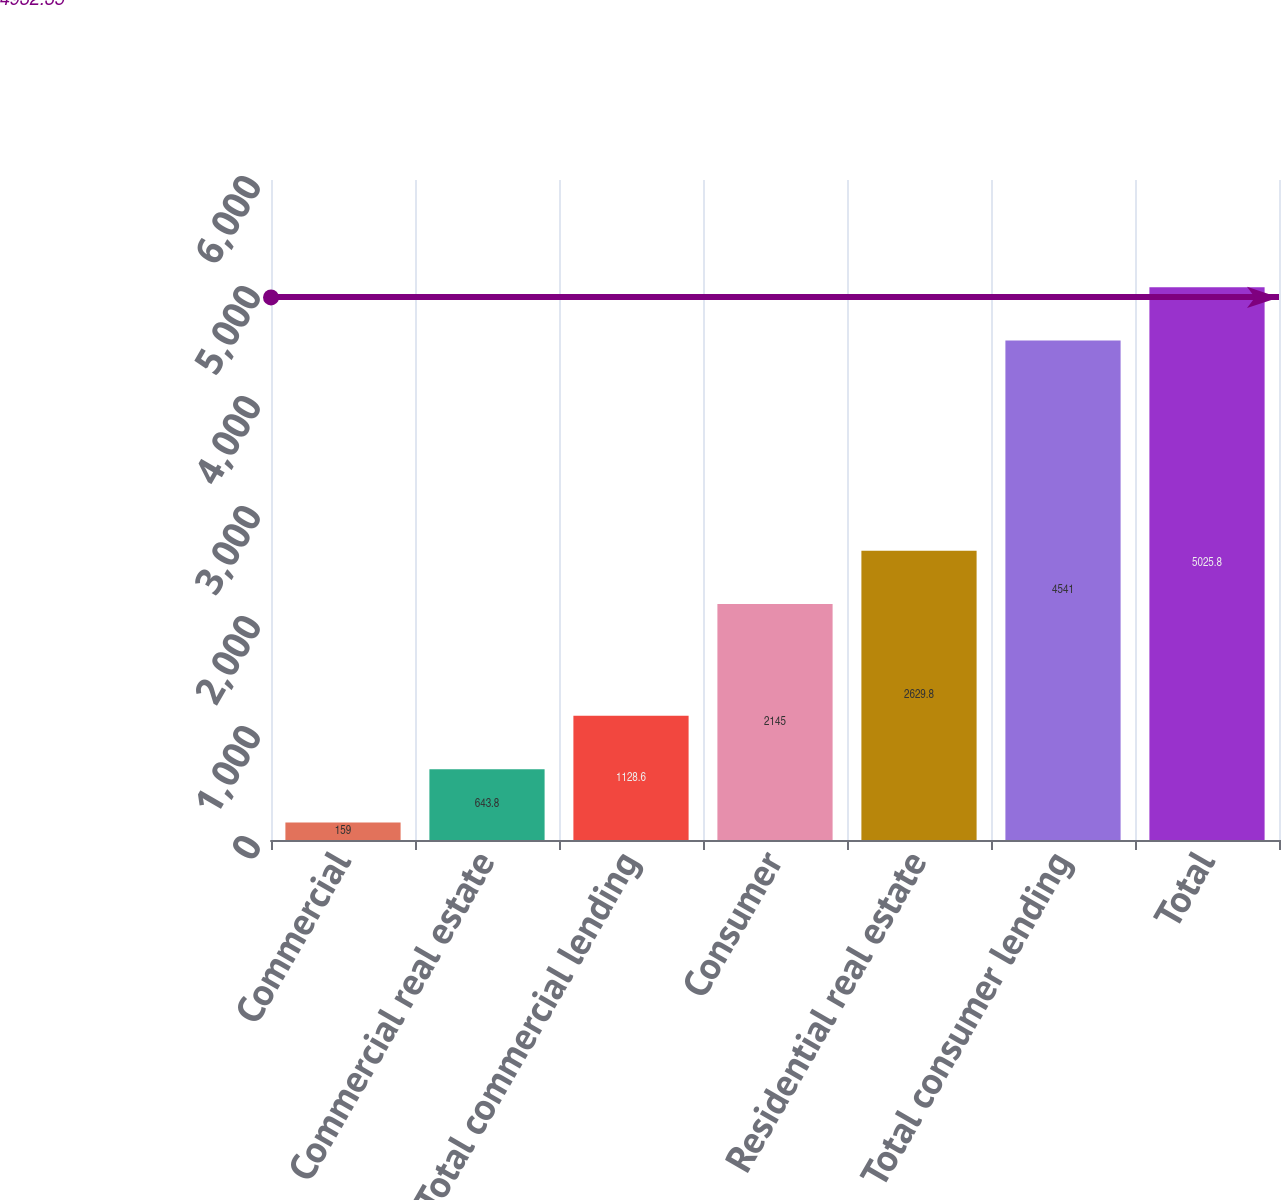Convert chart. <chart><loc_0><loc_0><loc_500><loc_500><bar_chart><fcel>Commercial<fcel>Commercial real estate<fcel>Total commercial lending<fcel>Consumer<fcel>Residential real estate<fcel>Total consumer lending<fcel>Total<nl><fcel>159<fcel>643.8<fcel>1128.6<fcel>2145<fcel>2629.8<fcel>4541<fcel>5025.8<nl></chart> 